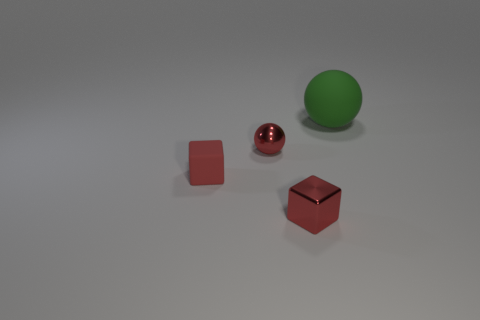Add 1 red metallic cubes. How many objects exist? 5 Subtract 0 gray cylinders. How many objects are left? 4 Subtract all large purple metal blocks. Subtract all tiny red cubes. How many objects are left? 2 Add 2 big rubber balls. How many big rubber balls are left? 3 Add 3 red blocks. How many red blocks exist? 5 